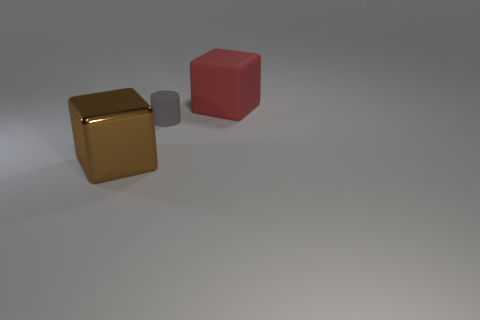Add 3 small matte cylinders. How many objects exist? 6 Subtract all cylinders. How many objects are left? 2 Add 1 green cubes. How many green cubes exist? 1 Subtract 0 red balls. How many objects are left? 3 Subtract all tiny green cylinders. Subtract all shiny blocks. How many objects are left? 2 Add 1 matte cubes. How many matte cubes are left? 2 